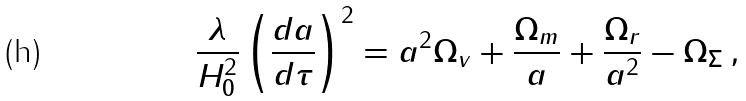Convert formula to latex. <formula><loc_0><loc_0><loc_500><loc_500>\frac { \lambda } { H _ { 0 } ^ { 2 } } \left ( { \frac { d a } { d \tau } } \right ) ^ { 2 } = a ^ { 2 } \Omega _ { v } + \frac { \Omega _ { m } } { a } + \frac { \Omega _ { r } } { a ^ { 2 } } - \Omega _ { \Sigma } \, ,</formula> 